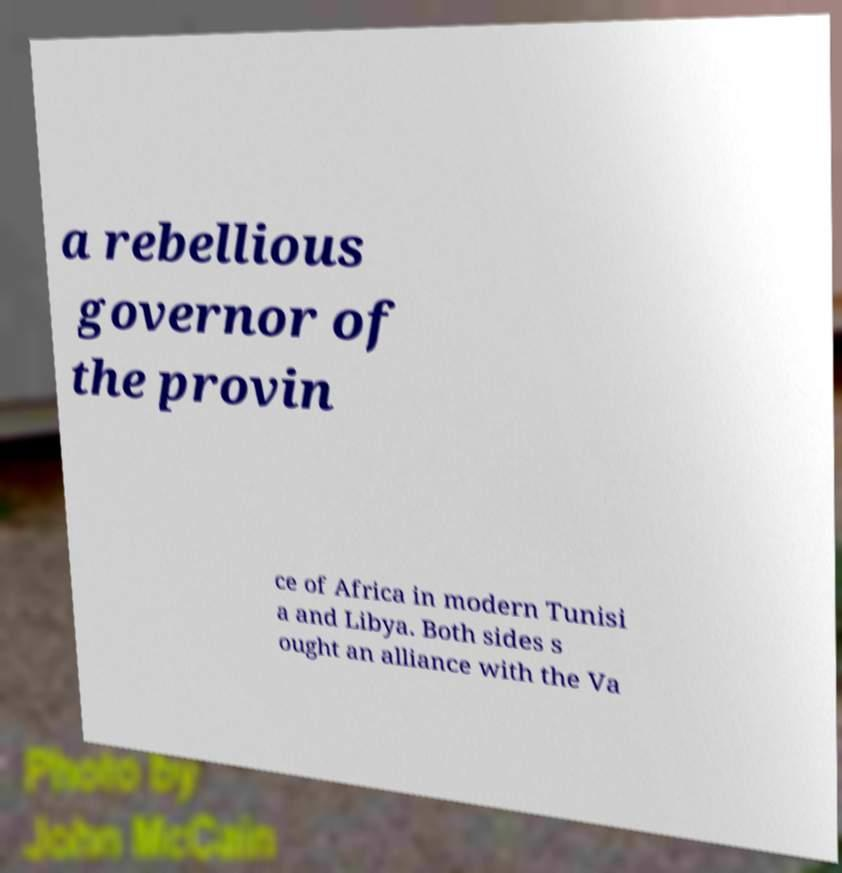Can you read and provide the text displayed in the image?This photo seems to have some interesting text. Can you extract and type it out for me? a rebellious governor of the provin ce of Africa in modern Tunisi a and Libya. Both sides s ought an alliance with the Va 